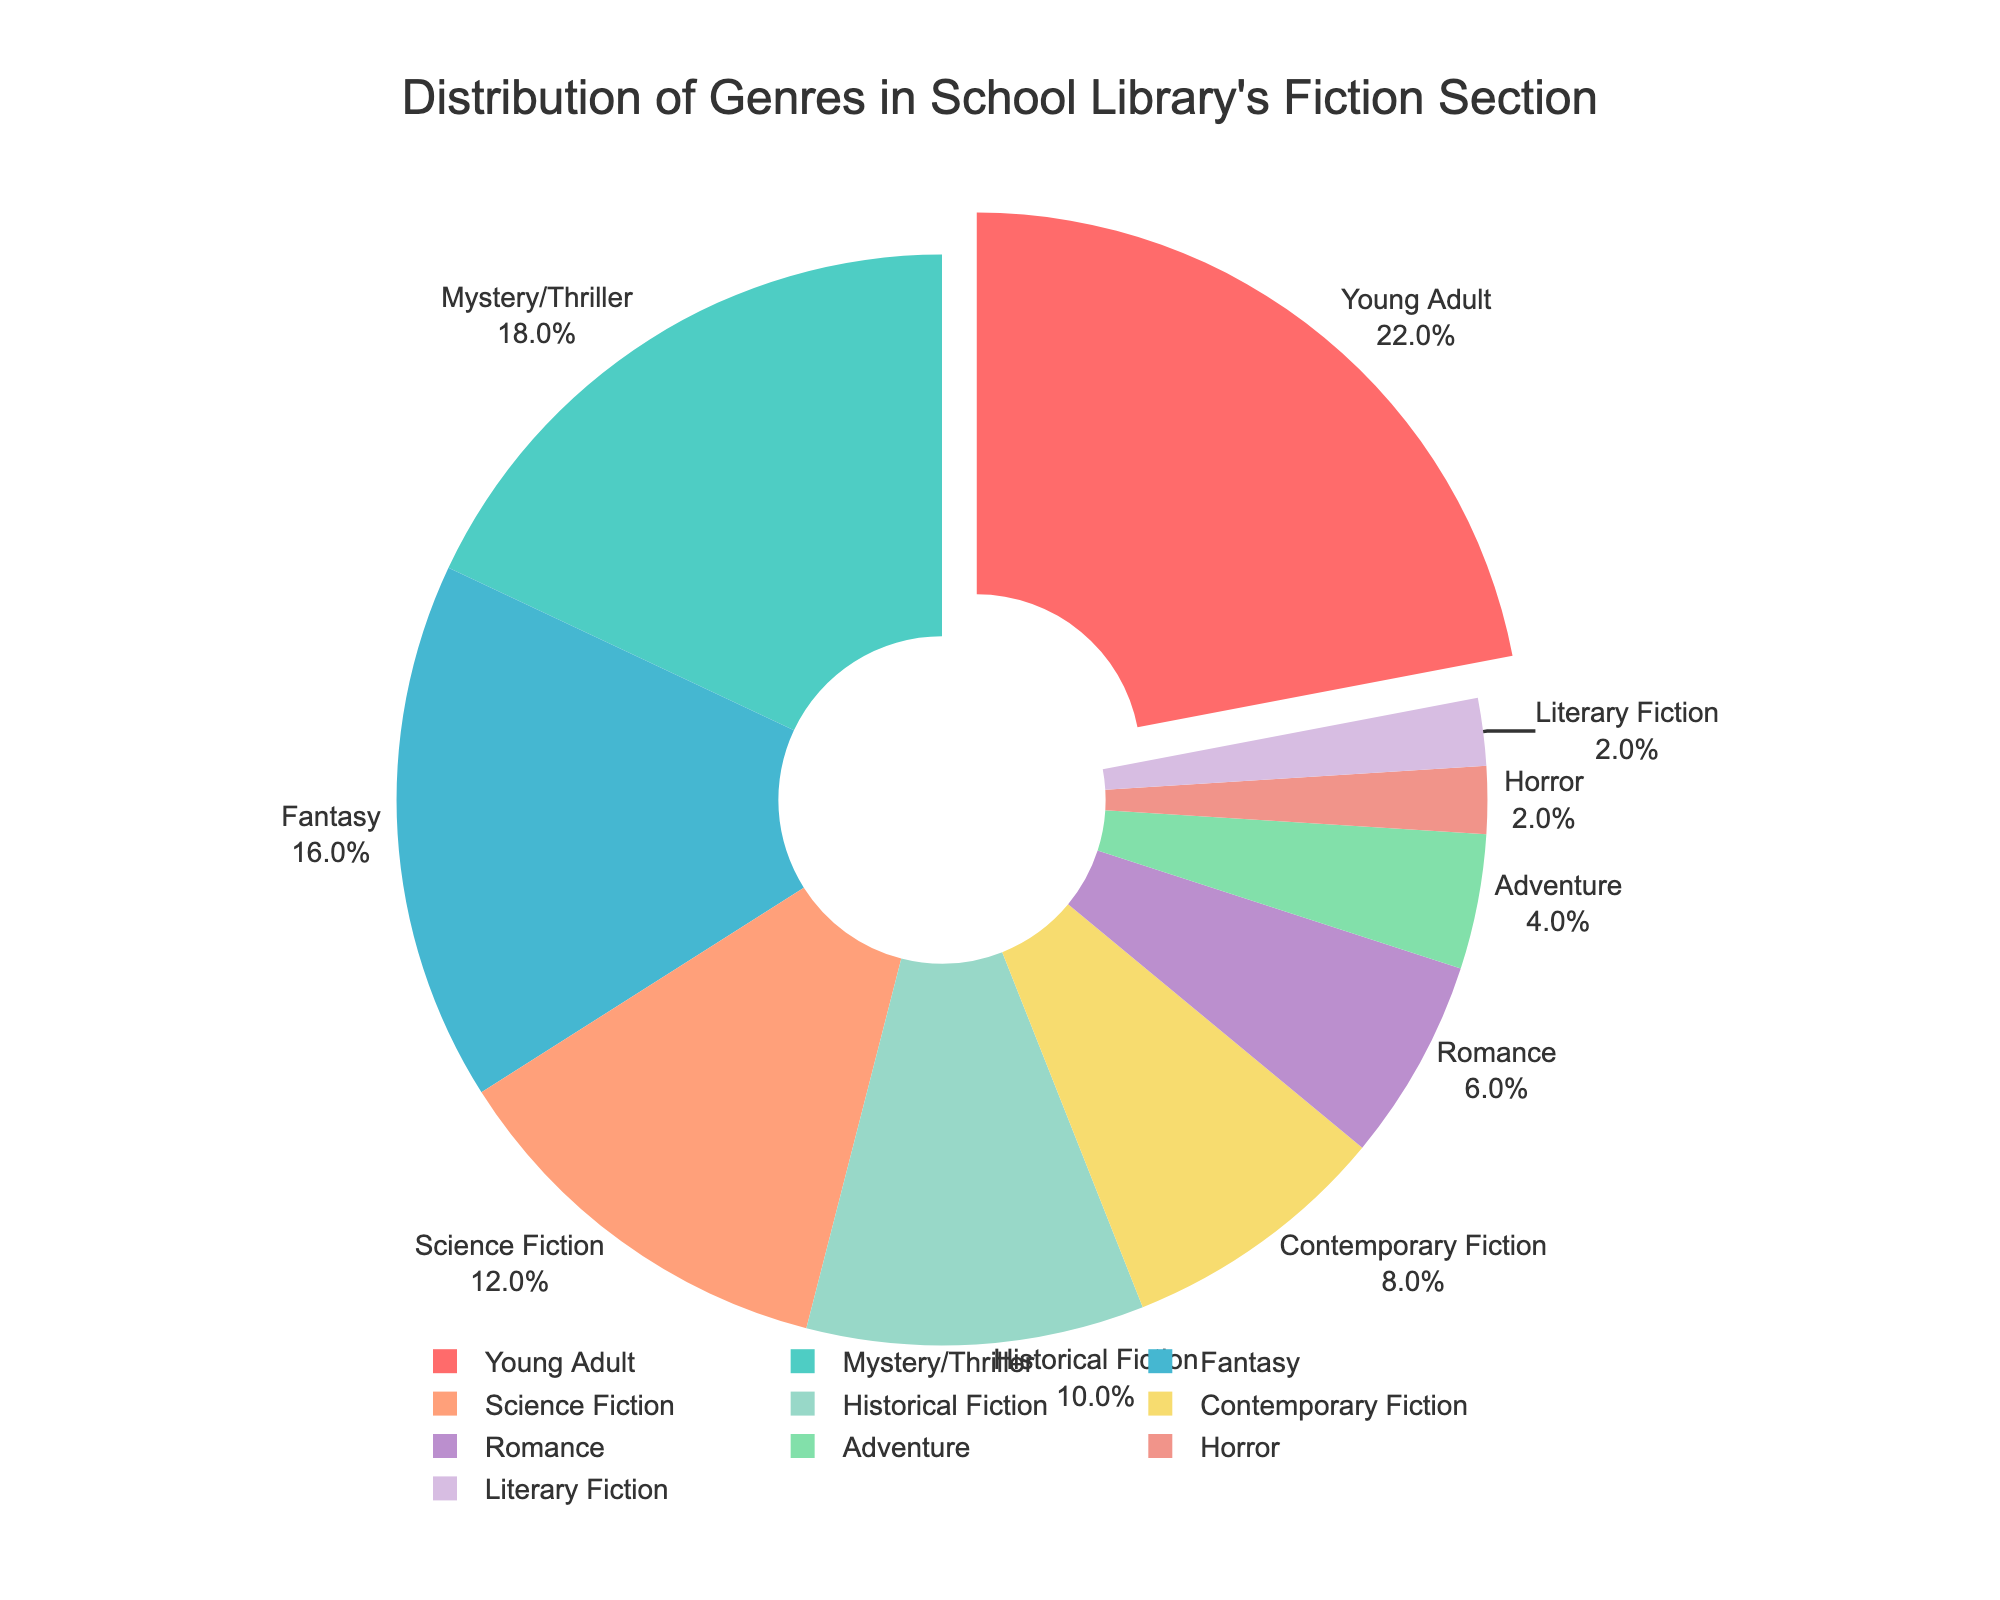what is the most represented genre in the library's fiction section? The pie chart visually highlights the Young Adult genre by pulling its segment out slightly, indicating it has the largest percentage.
Answer: Young Adult Which genres have equal representation in the library's fiction section? The pie chart shows that Horror and Literary Fiction each occupy 2% of the total, making their representation equal.
Answer: Horror and Literary Fiction How many genres in the library's fiction section have a percentage higher than Romance? Romance has 6%. The genres with higher percentages are Young Adult (22%), Mystery/Thriller (18%), Fantasy (16%), Science Fiction (12%), Historical Fiction (10%), and Contemporary Fiction (8%). Counting these gives us six genres.
Answer: 6 Compare the percentages of Adventure and Contemporary Fiction. How much greater is Contemporary Fiction's percentage compared to Adventure? Contemporary Fiction is 8% and Adventure is 4%. The difference between them is 8% - 4% = 4%.
Answer: 4% Which genre occupies exactly half the percentage of Science Fiction? Science Fiction occupies 12%. Half of 12% is 6%, which is the percentage of the Romance genre.
Answer: Romance Combine the percentages of the three least represented genres. What is their total percentage? The least represented genres are Horror (2%), Literary Fiction (2%), and Adventure (4%). Summing these gives 2% + 2% + 4% = 8%.
Answer: 8% Which color represents the Historical Fiction genre in the pie chart? The pie chart colors are listed corresponding to the order in the dataset. The sixth genre, Historical Fiction, is represented by the sixth color in the given list, which is #98D8C8 (a light green color).
Answer: Light green Arrange the top three represented genres in descending order of their percentage. The top three genres by percentage are Young Adult (22%), Mystery/Thriller (18%), and Fantasy (16%), listed in descending order.
Answer: Young Adult, Mystery/Thriller, Fantasy What's the combined percentage of all genres that have a representation of 10% or more? The genres with 10% or more are Young Adult (22%), Mystery/Thriller (18%), Fantasy (16%), Science Fiction (12%), and Historical Fiction (10%). Summing these gives 22% + 18% + 16% + 12% + 10% = 78%.
Answer: 78% 